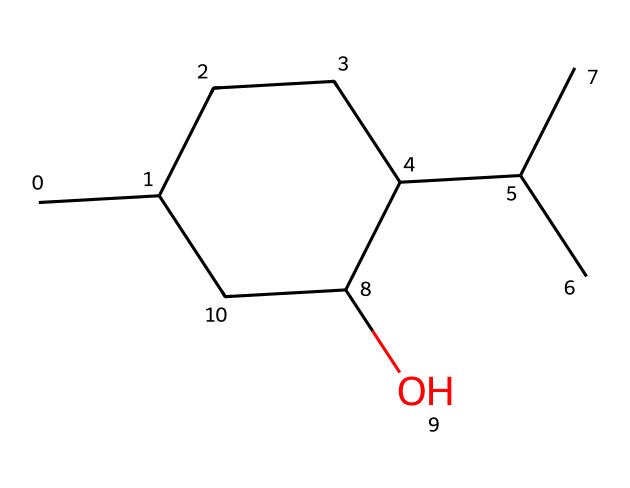How many carbon atoms are in menthol? The SMILES notation CC1CCC(C(C)C)C(O)C1 indicates there are seven carbon atoms in total, including the ones in the cyclic structure and all substituents.
Answer: seven What functional group is present in menthol? In the SMILES representation, the "C(O)" at the end indicates the presence of a hydroxyl group (-OH), which identifies it as an alcohol.
Answer: alcohol Is menthol a cyclic compound? The notation CC1...C1 suggests that the carbon atoms are arranged in a cycle (indicated by the '1'), confirming that it is a cyclic compound.
Answer: yes How many hydrogen atoms are in menthol? Each carbon in the molecule typically bonds to enough hydrogen atoms to complete four total bonds. By visualizing the structure or calculating from the SMILES, we find that there are 14 hydrogen atoms in total.
Answer: fourteen Which part of the structure contributes to menthol's cooling sensation? The presence of the hydroxyl group (-OH) and the arrangement of carbon atoms create specific interactions with receptors in the mouth, leading to the cooling sensation.
Answer: hydroxyl group What type of cycloalkane is menthol classified as? Menthol, with a carbon ring and branched alkyl groups, is a type of cyclohexanol, which is a cycloalkane with an alcohol functional group.
Answer: cyclohexanol Is menthol chiral? The presence of a carbon atom bonded to four different substituents indicates that menthol has a chiral center, making it a chiral molecule.
Answer: yes 